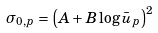Convert formula to latex. <formula><loc_0><loc_0><loc_500><loc_500>\sigma _ { 0 , p } = \left ( A + B \log \bar { u } _ { p } \right ) ^ { 2 }</formula> 